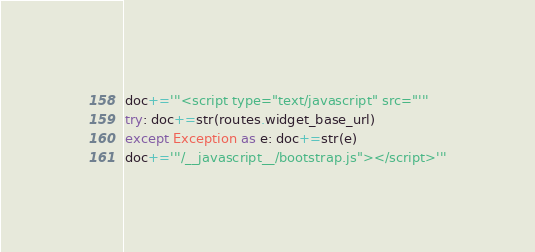Convert code to text. <code><loc_0><loc_0><loc_500><loc_500><_Python_>doc+='''<script type="text/javascript" src="'''
try: doc+=str(routes.widget_base_url)
except Exception as e: doc+=str(e)
doc+='''/__javascript__/bootstrap.js"></script>'''</code> 